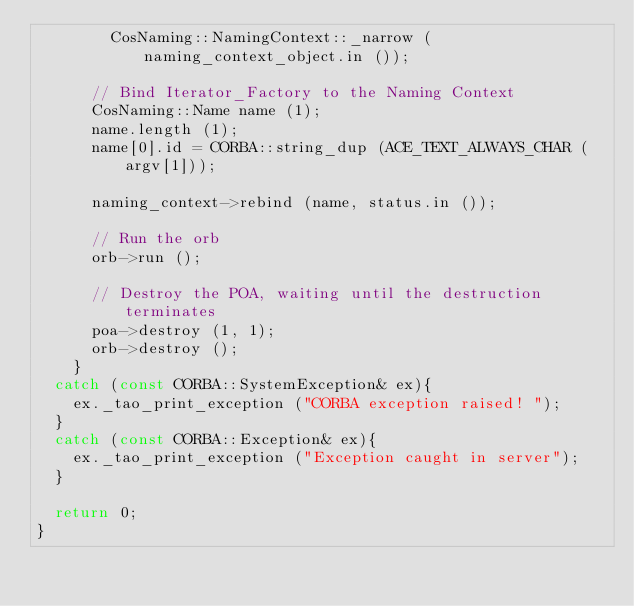Convert code to text. <code><loc_0><loc_0><loc_500><loc_500><_C++_>        CosNaming::NamingContext::_narrow (naming_context_object.in ());

      // Bind Iterator_Factory to the Naming Context
      CosNaming::Name name (1);
      name.length (1);
      name[0].id = CORBA::string_dup (ACE_TEXT_ALWAYS_CHAR (argv[1]));

      naming_context->rebind (name, status.in ());

      // Run the orb
      orb->run ();

      // Destroy the POA, waiting until the destruction terminates
      poa->destroy (1, 1);
      orb->destroy ();
    }
  catch (const CORBA::SystemException& ex){
    ex._tao_print_exception ("CORBA exception raised! ");
  }
  catch (const CORBA::Exception& ex){
    ex._tao_print_exception ("Exception caught in server");
  }

  return 0;
}
</code> 